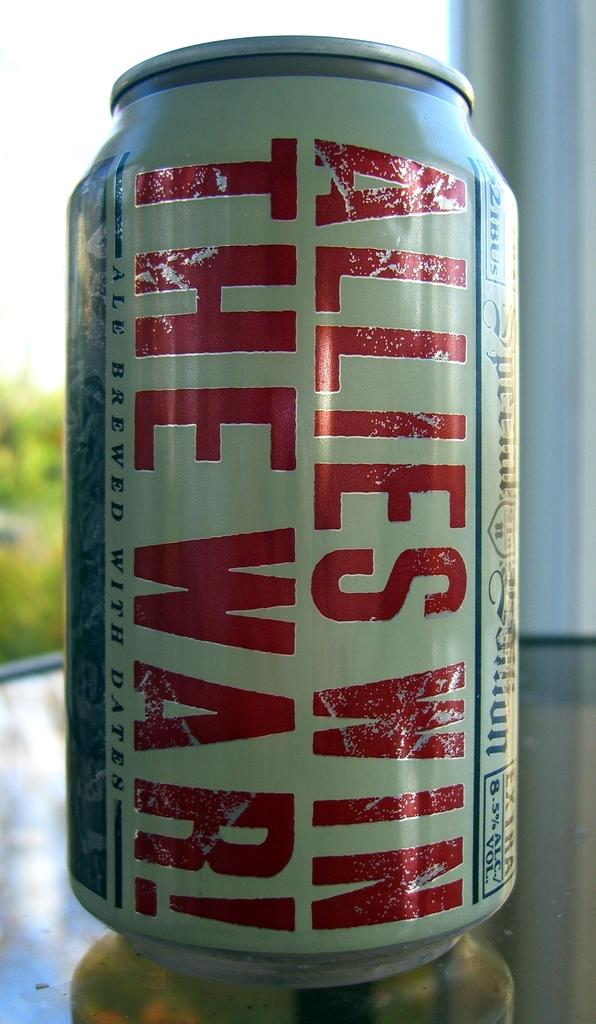<image>
Present a compact description of the photo's key features. The beer can has the slogan "Allies Win the War!". 